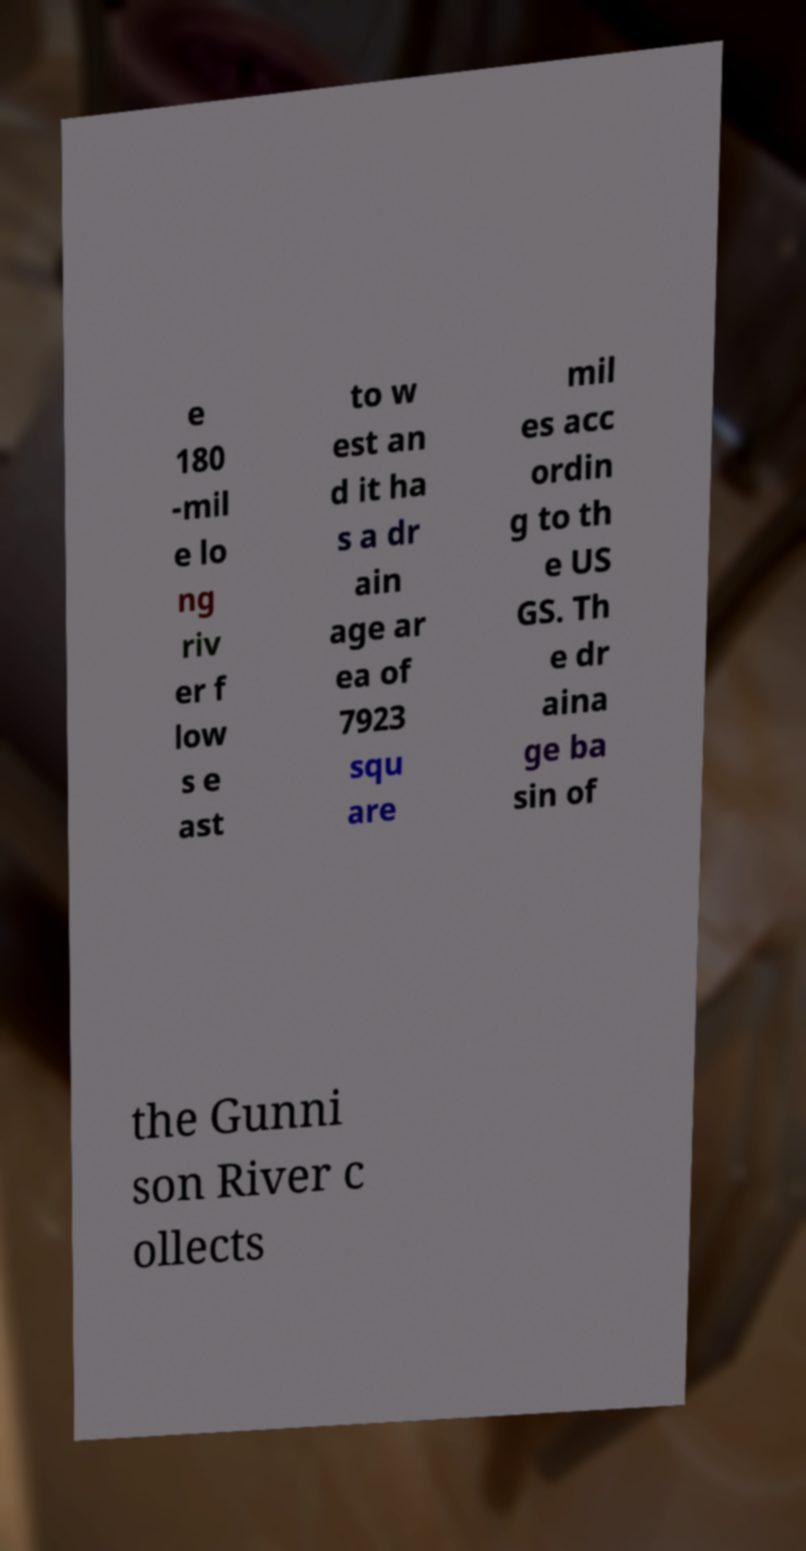For documentation purposes, I need the text within this image transcribed. Could you provide that? e 180 -mil e lo ng riv er f low s e ast to w est an d it ha s a dr ain age ar ea of 7923 squ are mil es acc ordin g to th e US GS. Th e dr aina ge ba sin of the Gunni son River c ollects 